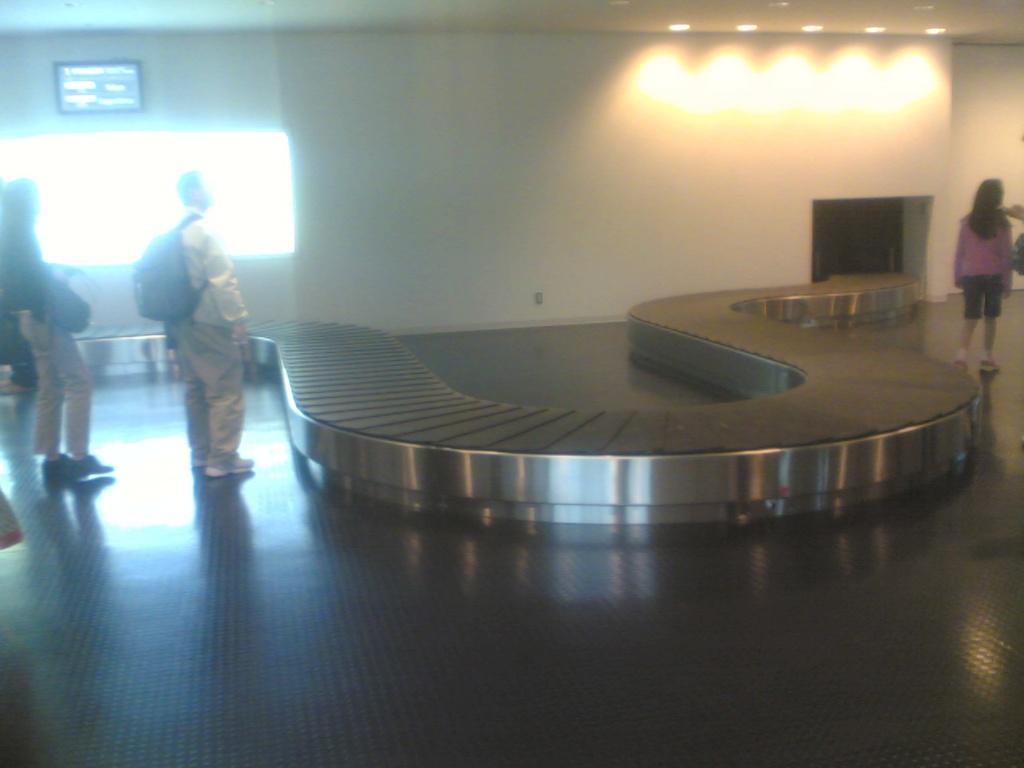Describe this image in one or two sentences. This picture is taken inside the room. In this image, on the right side, we can see a woman standing on the floor. On the right side, we can see hand of a person. On the right side, we can see a bag. On the left side, we can see two men are standing on the floor. In the background, we can see white color, monitor. In the background, we can also see a door and a light. In the middle of the image, we can see a bench. At the top, we can see a roof with few lights, at the bottom, we can see a floor. 